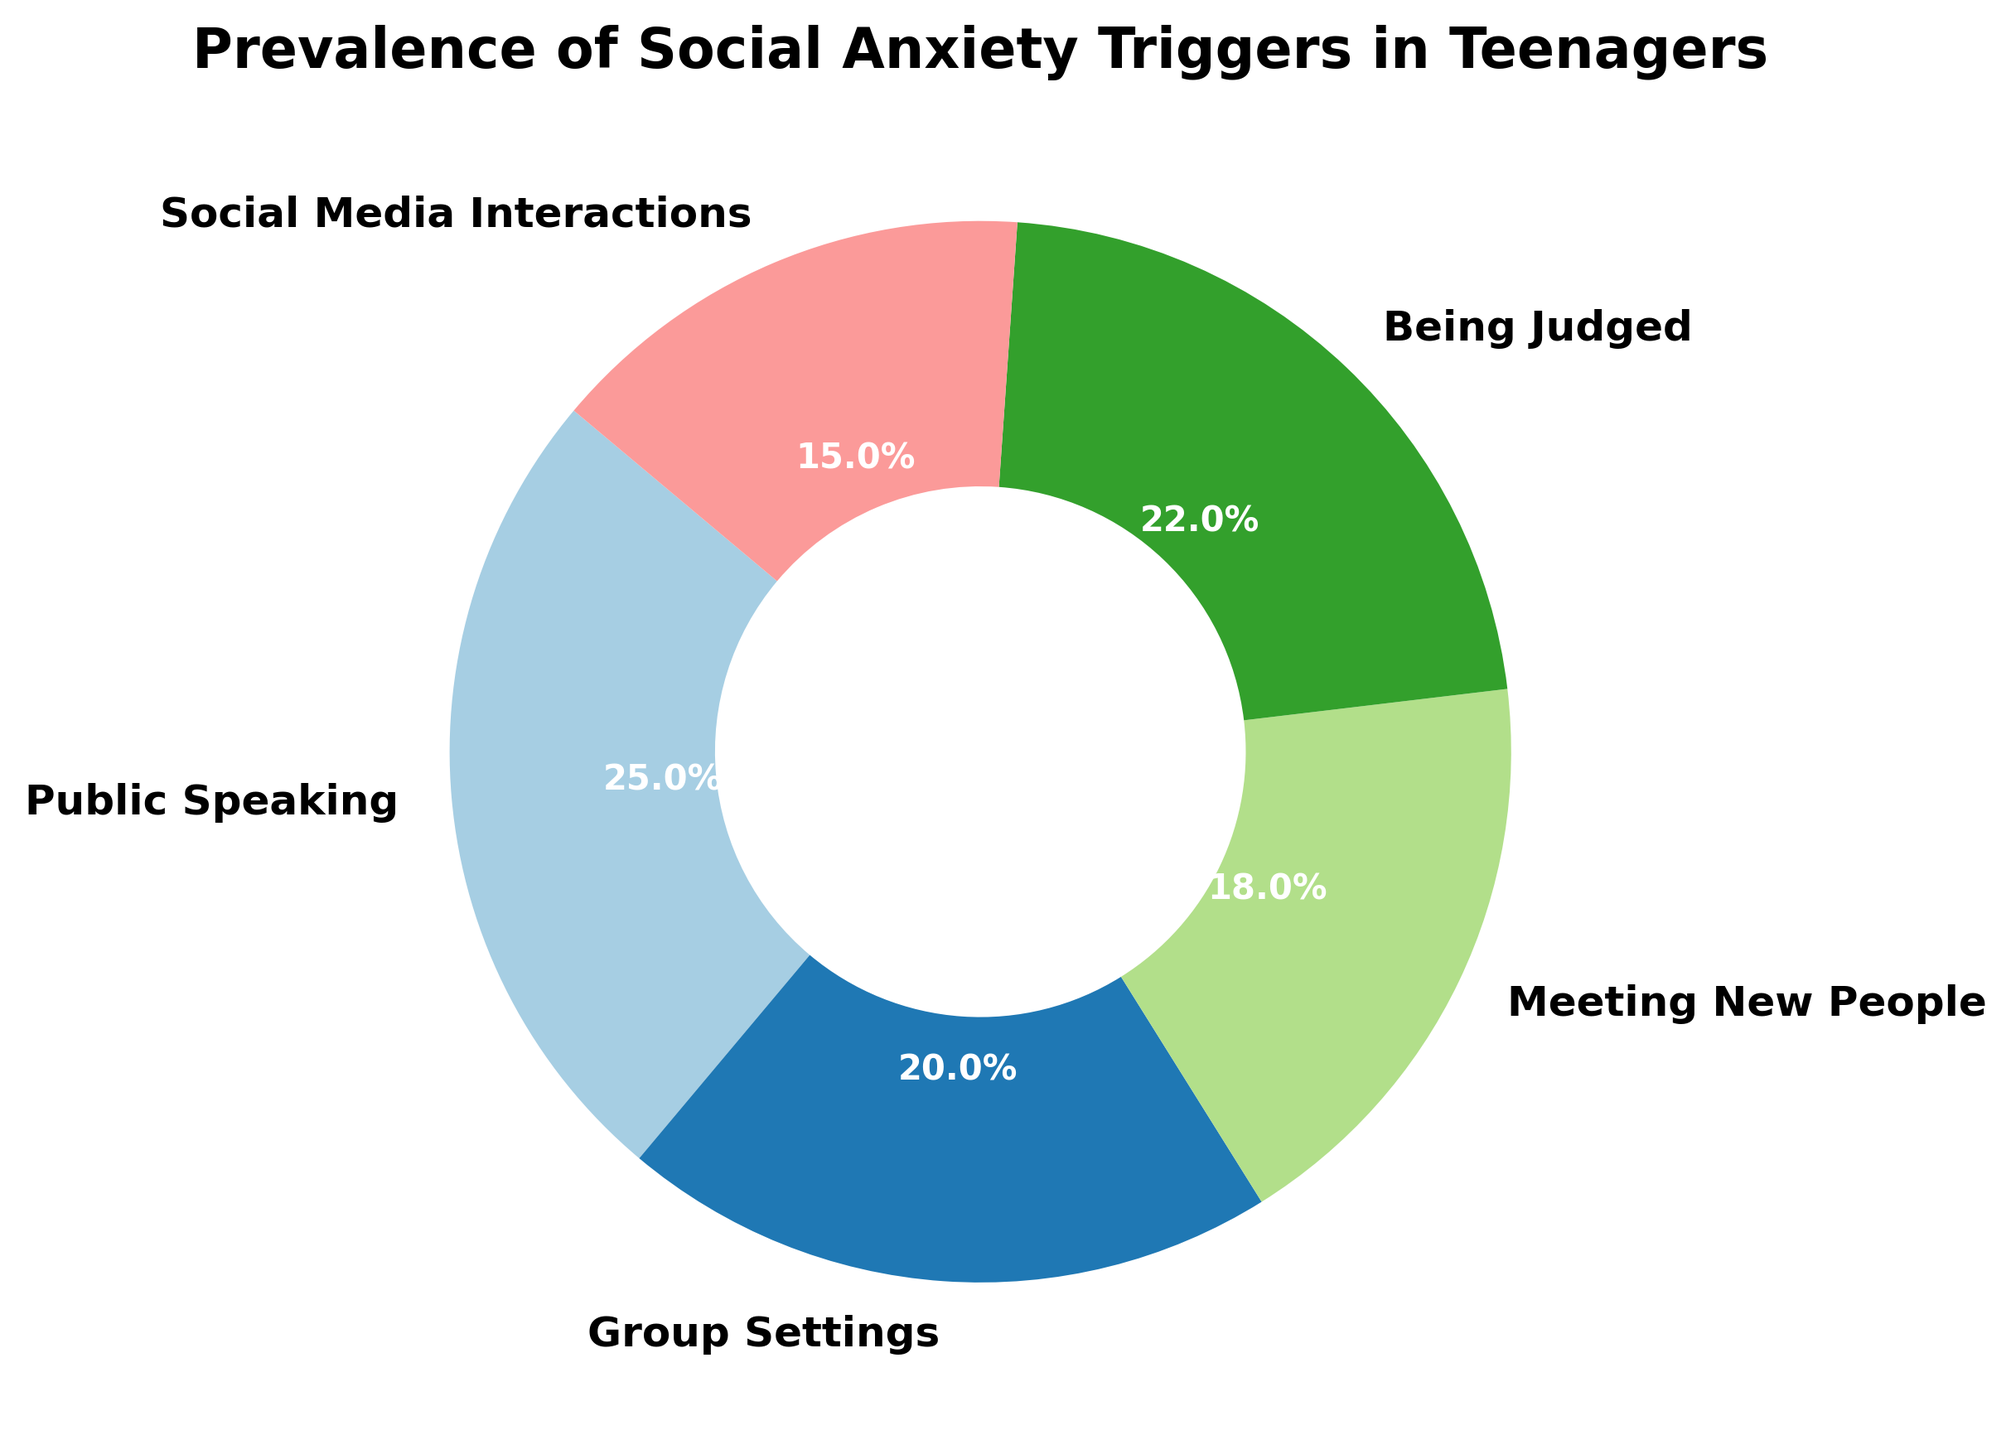What is the most common social anxiety trigger among teenagers according to the chart? The largest wedge in the donut chart represents Public Speaking with the highest percentage.
Answer: Public Speaking Which social anxiety trigger has the lowest percentage? The smallest wedge in the donut chart represents Social Media Interactions with the lowest percentage.
Answer: Social Media Interactions What is the combined percentage of teenagers who have anxiety in group settings and meeting new people? Group Settings has 20% and Meeting New People has 18%. Adding them together gives 38%.
Answer: 38% How does the prevalence of anxiety due to being judged compare to social media interactions? Being Judged accounts for 22%, while Social Media Interactions account for 15%. So, Being Judged is higher by 7%.
Answer: Being Judged is higher by 7% Which is more prevalent: anxiety in group settings or meeting new people? Group Settings is represented by 20%, whereas Meeting New People is represented by 18%, making Group Settings more prevalent.
Answer: Group Settings Is the percentage of teenagers with anxiety from public speaking greater than the percentage from being judged? Public Speaking accounts for 25% and Being Judged accounts for 22%. Since 25% is greater than 22%, Public Speaking is greater.
Answer: Yes What's the average percentage of teenagers across all social anxiety triggers? Summing up all the percentages (25 + 20 + 18 + 22 + 15) equals 100. Dividing by 5 gives an average of 20%.
Answer: 20% If you add the percentages of public speaking and social media interactions, would that be more than half of the total? Public Speaking is 25% and Social Media Interactions is 15%. Adding them together gives 40%, which is less than 50%.
Answer: No What is the sum of the percentages of the three least common social anxiety triggers? The three least common triggers are Social Media Interactions (15%), Meeting New People (18%), and Group Settings (20%). Adding them gives 53%.
Answer: 53% Among the triggers, which one is represented with the second highest percentage? Public Speaking has the highest at 25%, so Being Judged with 22% is the second highest.
Answer: Being Judged What color represents the wedge with the highest percentage in the chart? The wedge for Public Speaking, which has the highest percentage at 25%, is represented in dark blue.
Answer: Dark Blue 